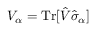Convert formula to latex. <formula><loc_0><loc_0><loc_500><loc_500>V _ { \alpha } = T r [ \hat { V } \hat { \sigma } _ { \alpha } ]</formula> 